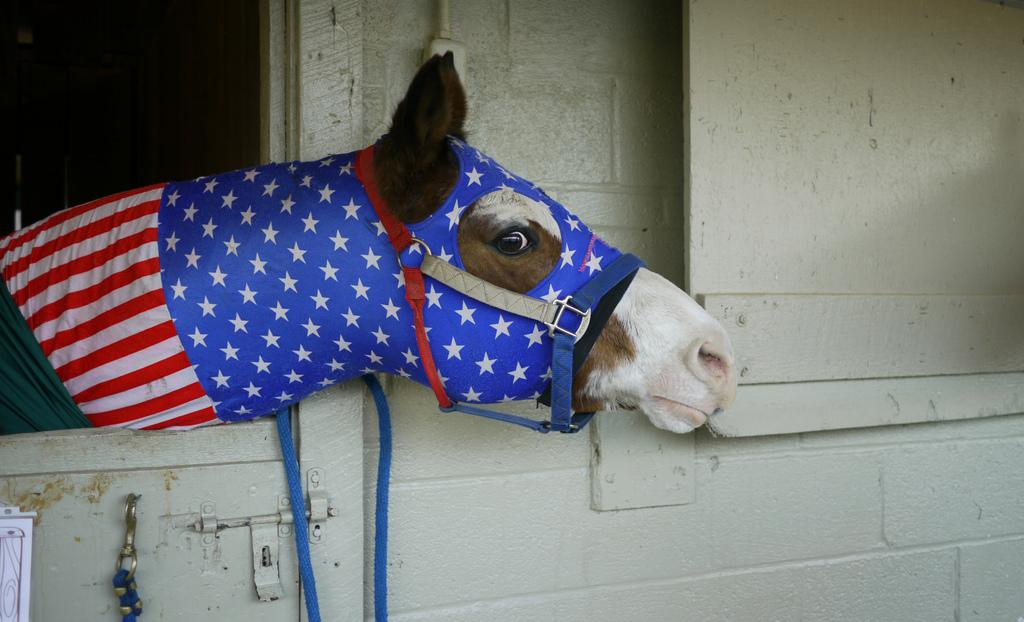What animal is present in the image? There is a horse in the image. What type of structure can be seen in the image? There is a wall in the image. What type of judge is sitting on the bed in the image? There are no judges or beds present in the image; it only features a horse and a wall. 